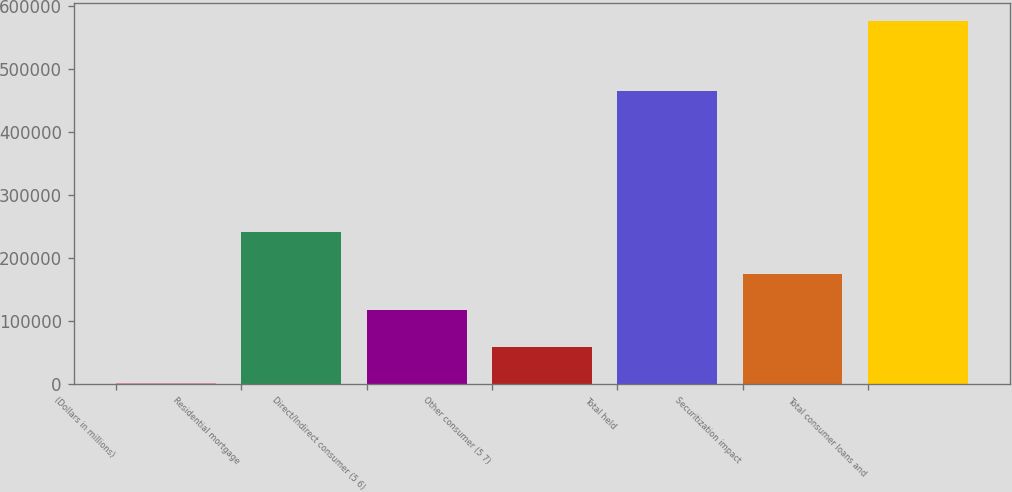Convert chart. <chart><loc_0><loc_0><loc_500><loc_500><bar_chart><fcel>(Dollars in millions)<fcel>Residential mortgage<fcel>Direct/Indirect consumer (5 6)<fcel>Other consumer (5 7)<fcel>Total held<fcel>Securitization impact<fcel>Total consumer loans and<nl><fcel>2006<fcel>241181<fcel>116776<fcel>59391<fcel>465705<fcel>174161<fcel>575856<nl></chart> 